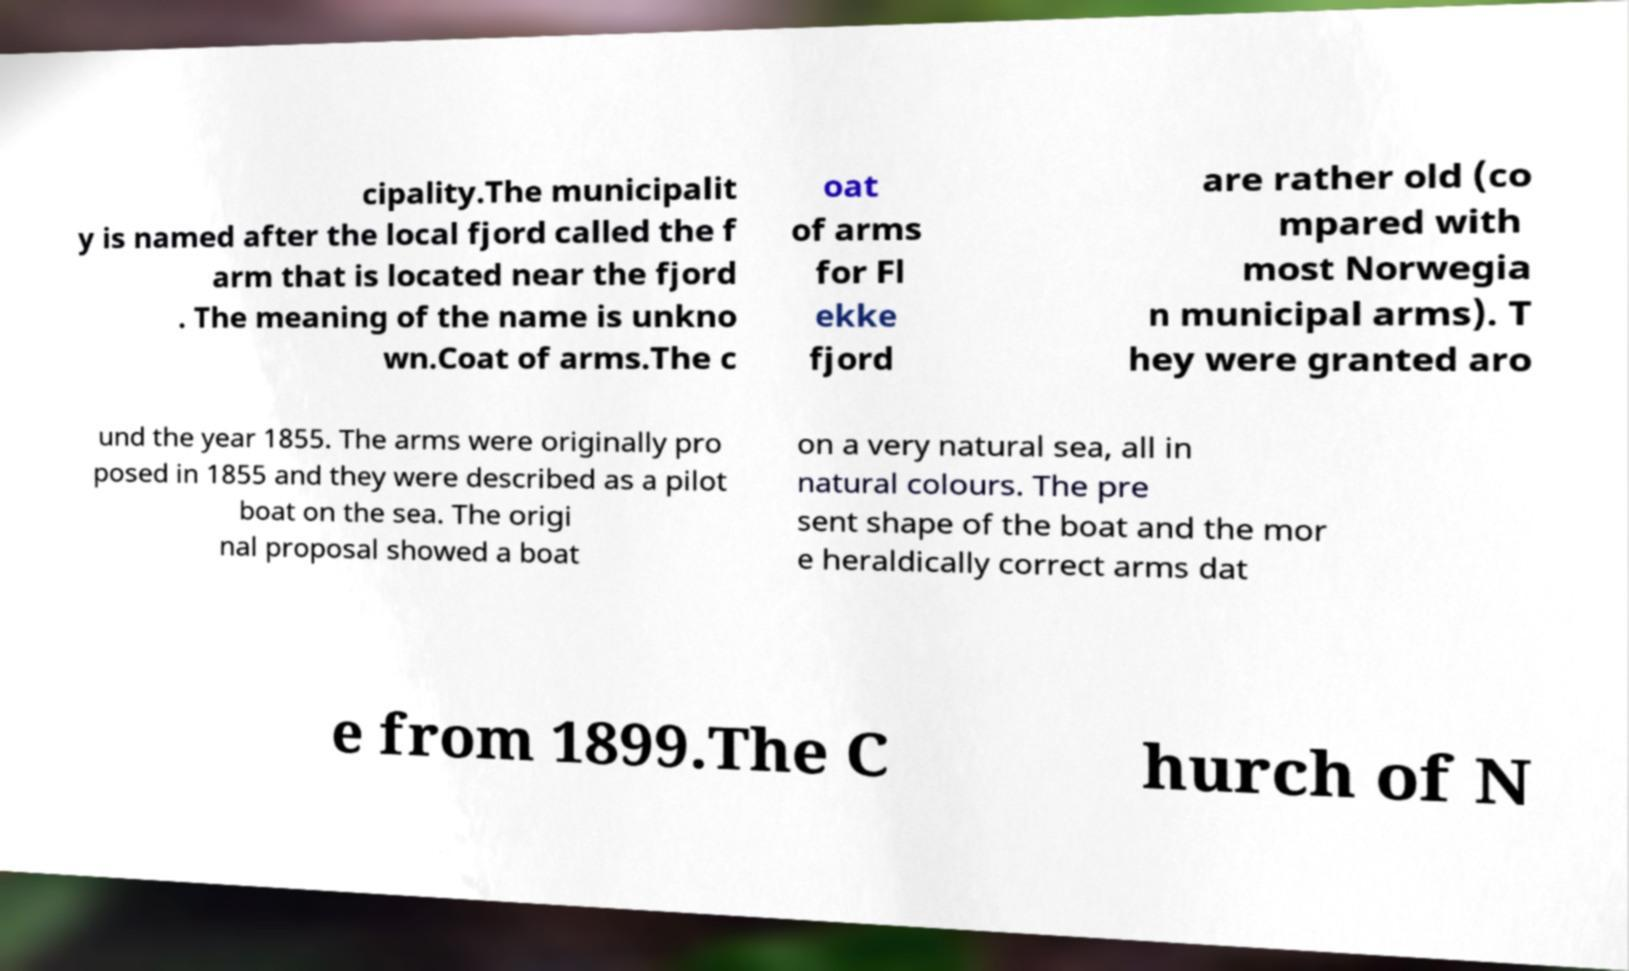Can you read and provide the text displayed in the image?This photo seems to have some interesting text. Can you extract and type it out for me? cipality.The municipalit y is named after the local fjord called the f arm that is located near the fjord . The meaning of the name is unkno wn.Coat of arms.The c oat of arms for Fl ekke fjord are rather old (co mpared with most Norwegia n municipal arms). T hey were granted aro und the year 1855. The arms were originally pro posed in 1855 and they were described as a pilot boat on the sea. The origi nal proposal showed a boat on a very natural sea, all in natural colours. The pre sent shape of the boat and the mor e heraldically correct arms dat e from 1899.The C hurch of N 